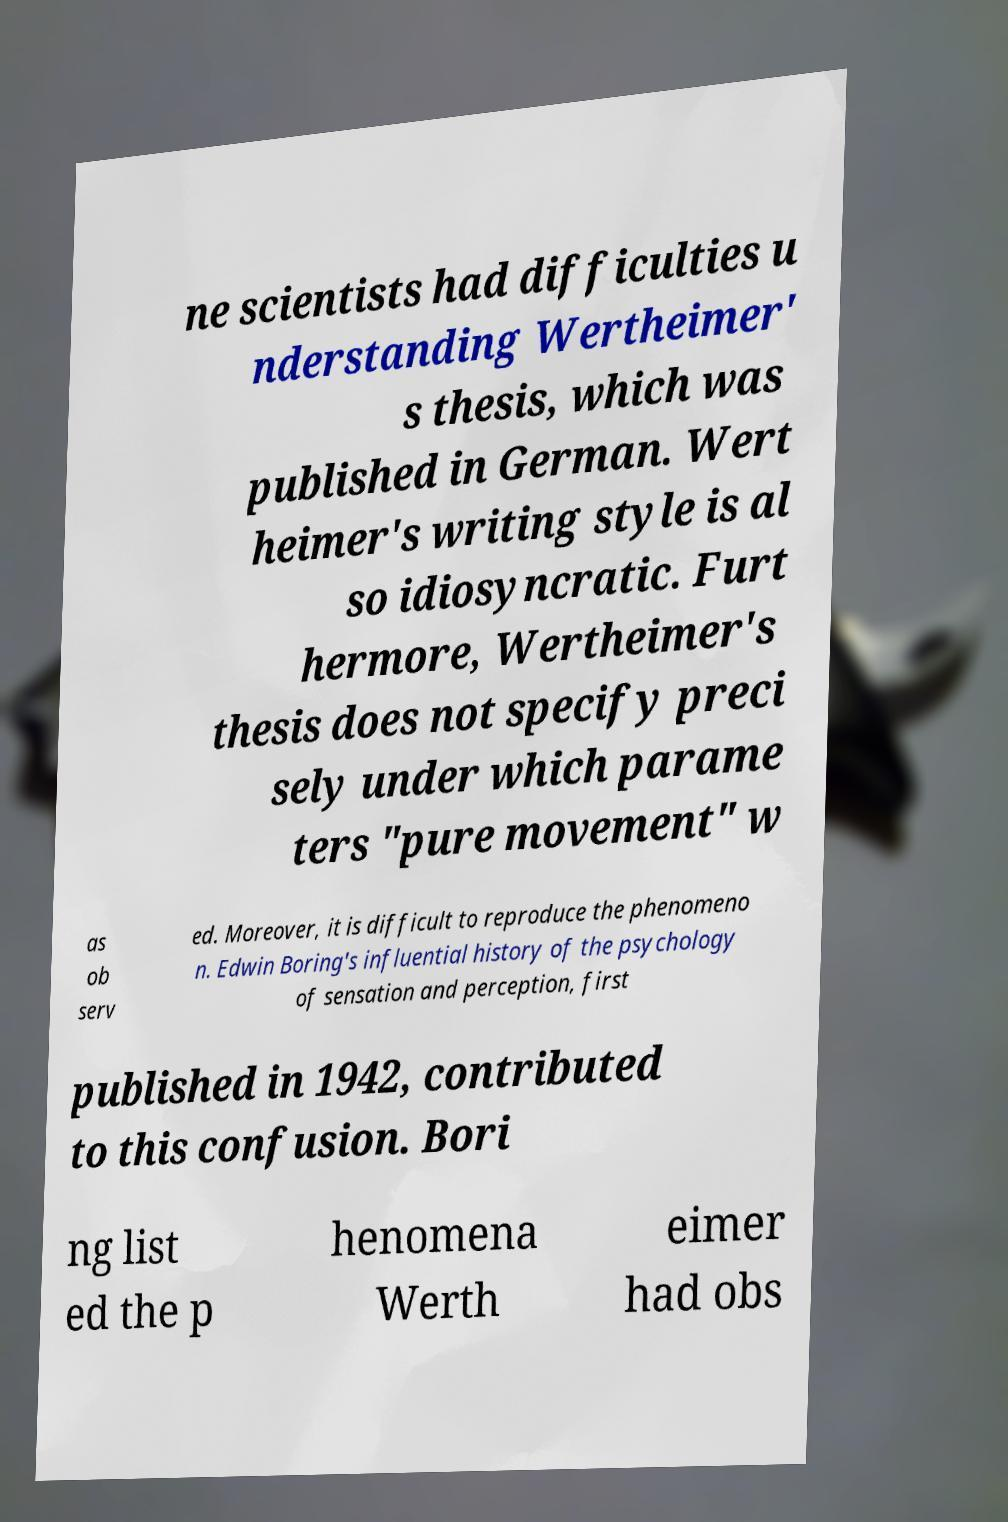Could you extract and type out the text from this image? ne scientists had difficulties u nderstanding Wertheimer' s thesis, which was published in German. Wert heimer's writing style is al so idiosyncratic. Furt hermore, Wertheimer's thesis does not specify preci sely under which parame ters "pure movement" w as ob serv ed. Moreover, it is difficult to reproduce the phenomeno n. Edwin Boring's influential history of the psychology of sensation and perception, first published in 1942, contributed to this confusion. Bori ng list ed the p henomena Werth eimer had obs 